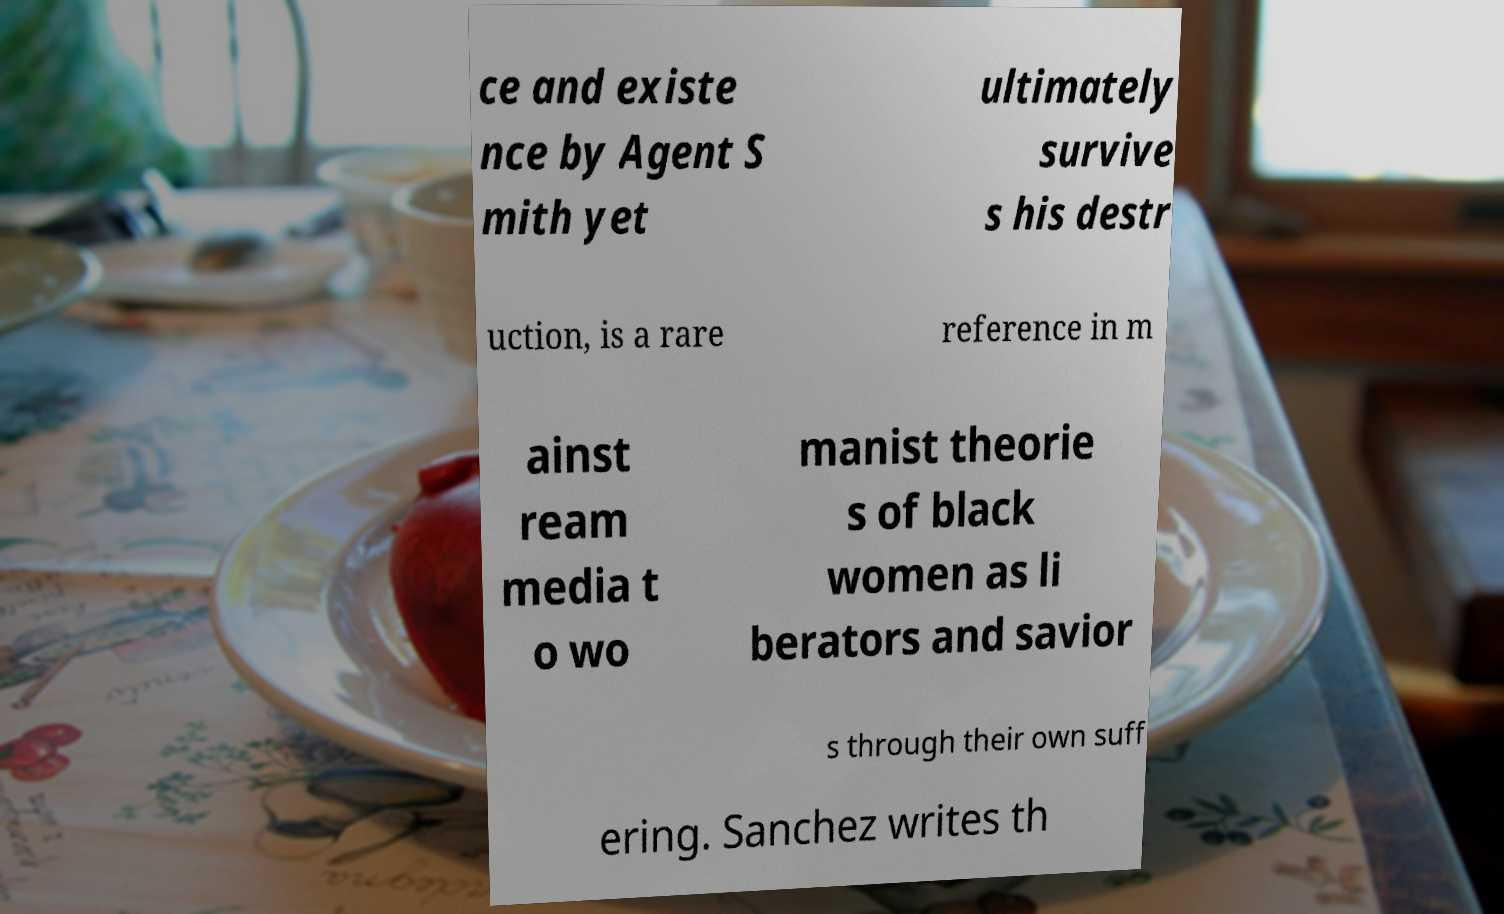Can you read and provide the text displayed in the image?This photo seems to have some interesting text. Can you extract and type it out for me? ce and existe nce by Agent S mith yet ultimately survive s his destr uction, is a rare reference in m ainst ream media t o wo manist theorie s of black women as li berators and savior s through their own suff ering. Sanchez writes th 